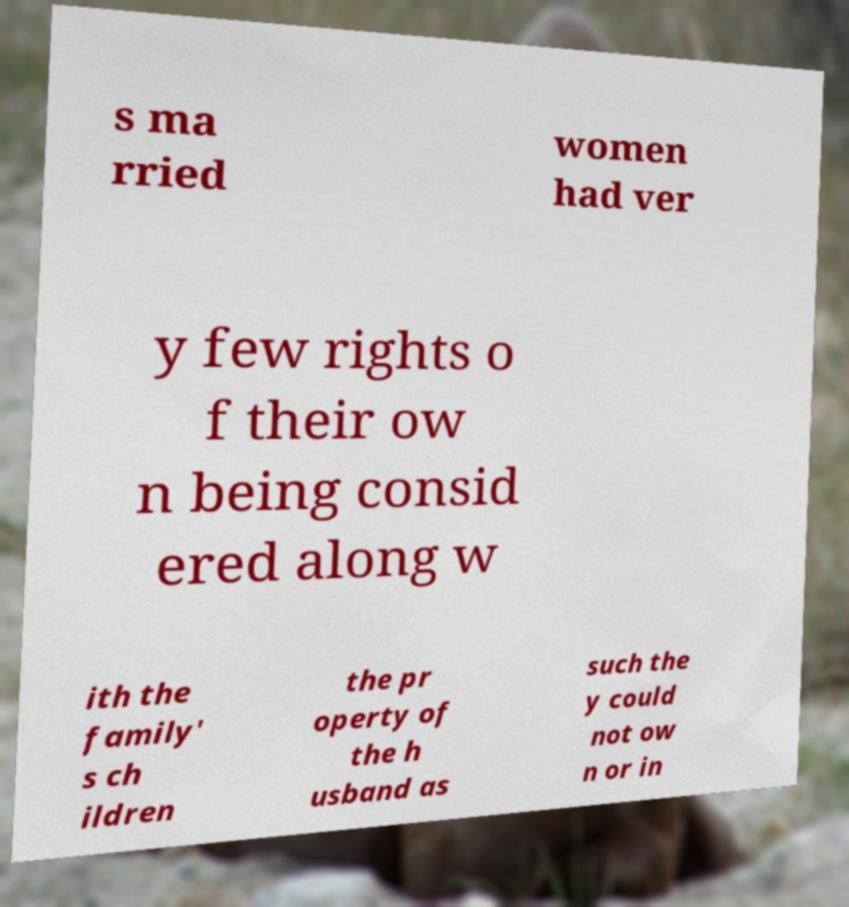Please read and relay the text visible in this image. What does it say? s ma rried women had ver y few rights o f their ow n being consid ered along w ith the family' s ch ildren the pr operty of the h usband as such the y could not ow n or in 